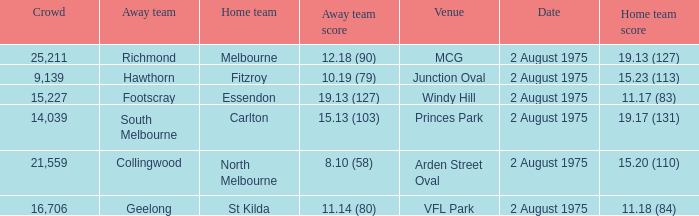When did the game at Arden Street Oval occur? 2 August 1975. 